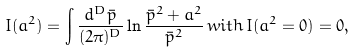Convert formula to latex. <formula><loc_0><loc_0><loc_500><loc_500>I ( a ^ { 2 } ) = \int \frac { d ^ { D } \bar { p } } { ( 2 \pi ) ^ { D } } \ln \frac { \bar { p } ^ { 2 } + a ^ { 2 } } { \bar { p } ^ { 2 } } \, w i t h \, I ( a ^ { 2 } = 0 ) = 0 ,</formula> 